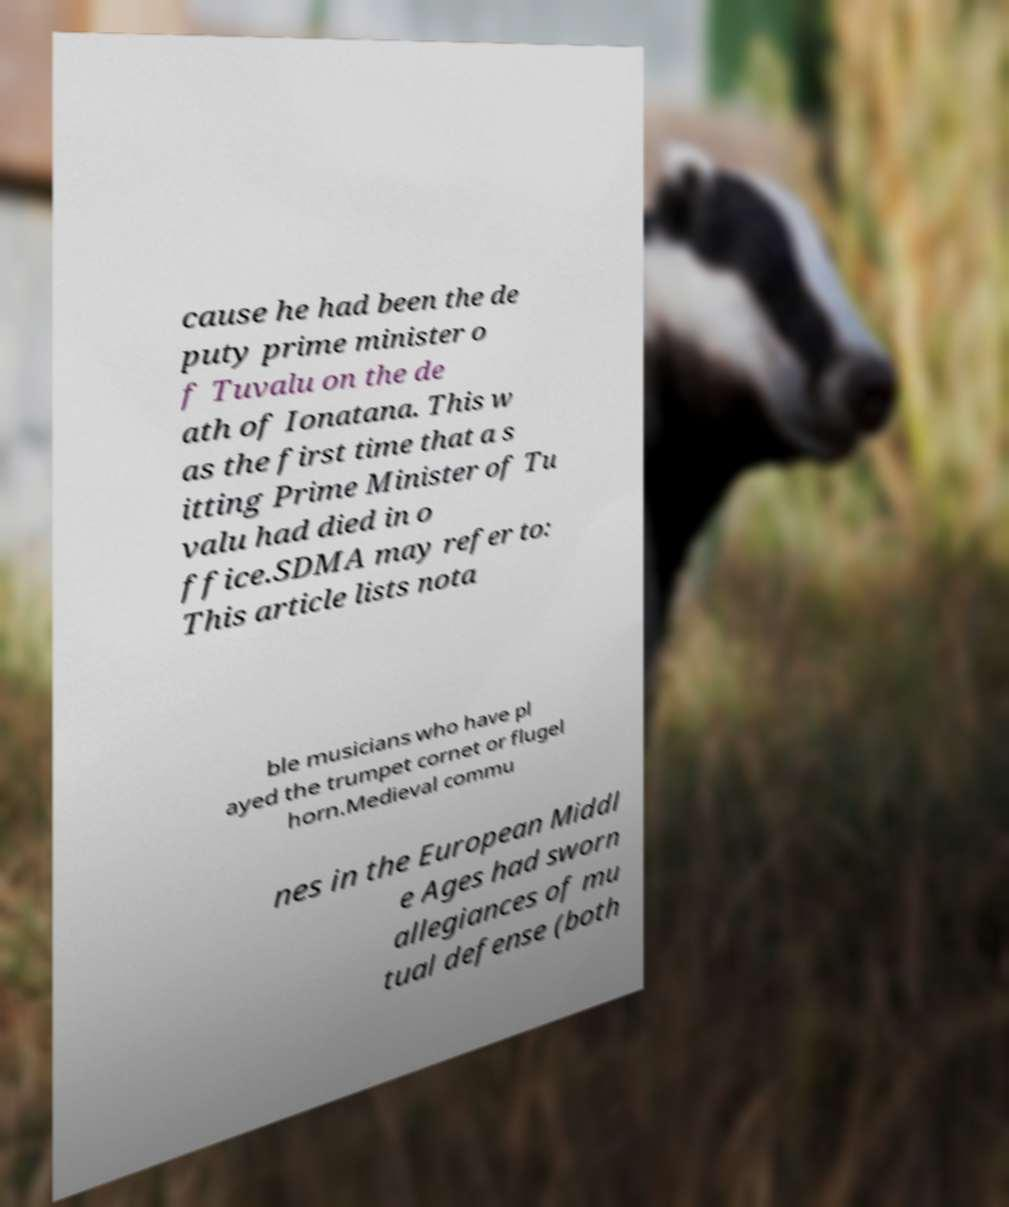What messages or text are displayed in this image? I need them in a readable, typed format. cause he had been the de puty prime minister o f Tuvalu on the de ath of Ionatana. This w as the first time that a s itting Prime Minister of Tu valu had died in o ffice.SDMA may refer to: This article lists nota ble musicians who have pl ayed the trumpet cornet or flugel horn.Medieval commu nes in the European Middl e Ages had sworn allegiances of mu tual defense (both 